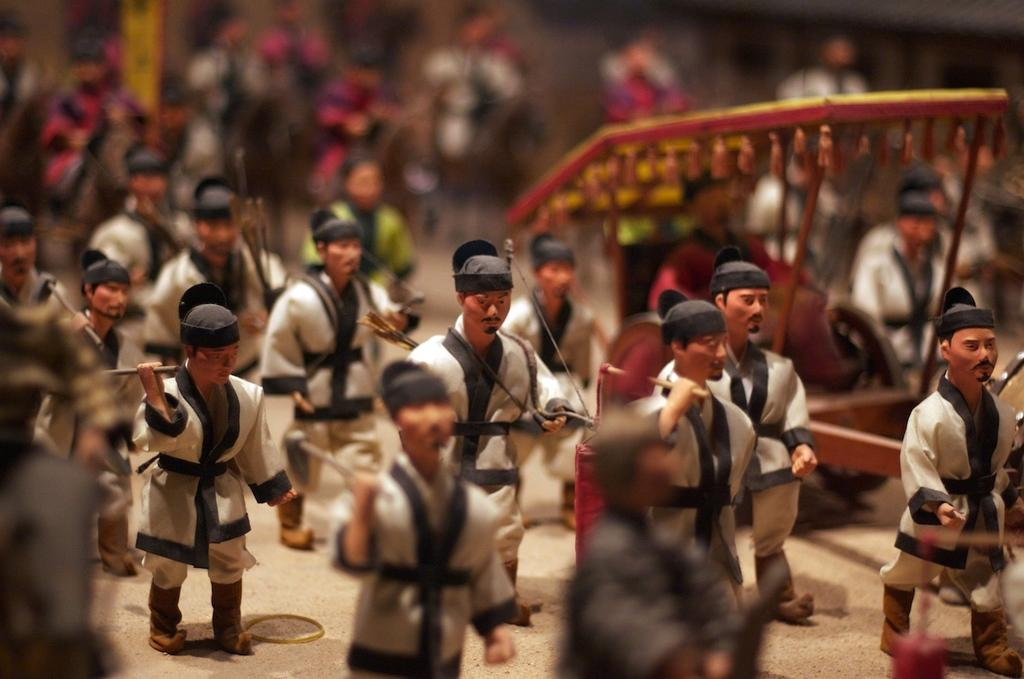What type of objects are depicted in the image? There are miniatures of persons in the image. Can you describe the background of the image? The background of the image is blurry. What type of metal is used to make the coach in the image? There is no coach present in the image, so it is not possible to determine what type of metal might be used. 